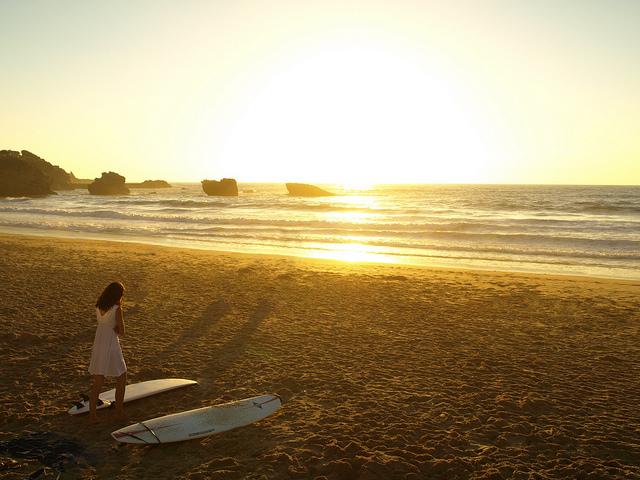Can you see the sun?
Give a very brief answer. Yes. Is that a man or a woman?
Answer briefly. Woman. What is the gender of the human?
Write a very short answer. Female. Is her clothing appropriate for surfing?
Write a very short answer. No. Is the sun rising?
Write a very short answer. Yes. 